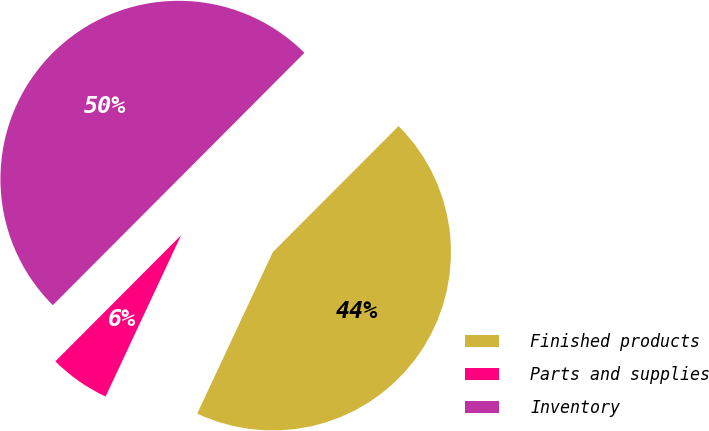<chart> <loc_0><loc_0><loc_500><loc_500><pie_chart><fcel>Finished products<fcel>Parts and supplies<fcel>Inventory<nl><fcel>44.49%<fcel>5.51%<fcel>50.0%<nl></chart> 